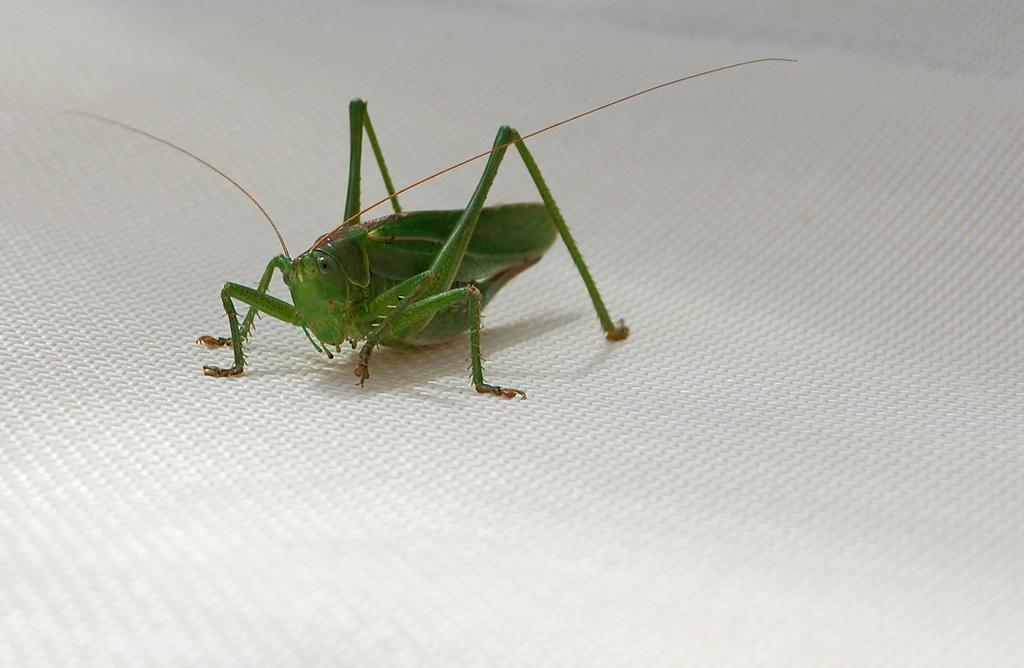How would you summarize this image in a sentence or two? It is a zoom in picture of a locust on the white surface. 